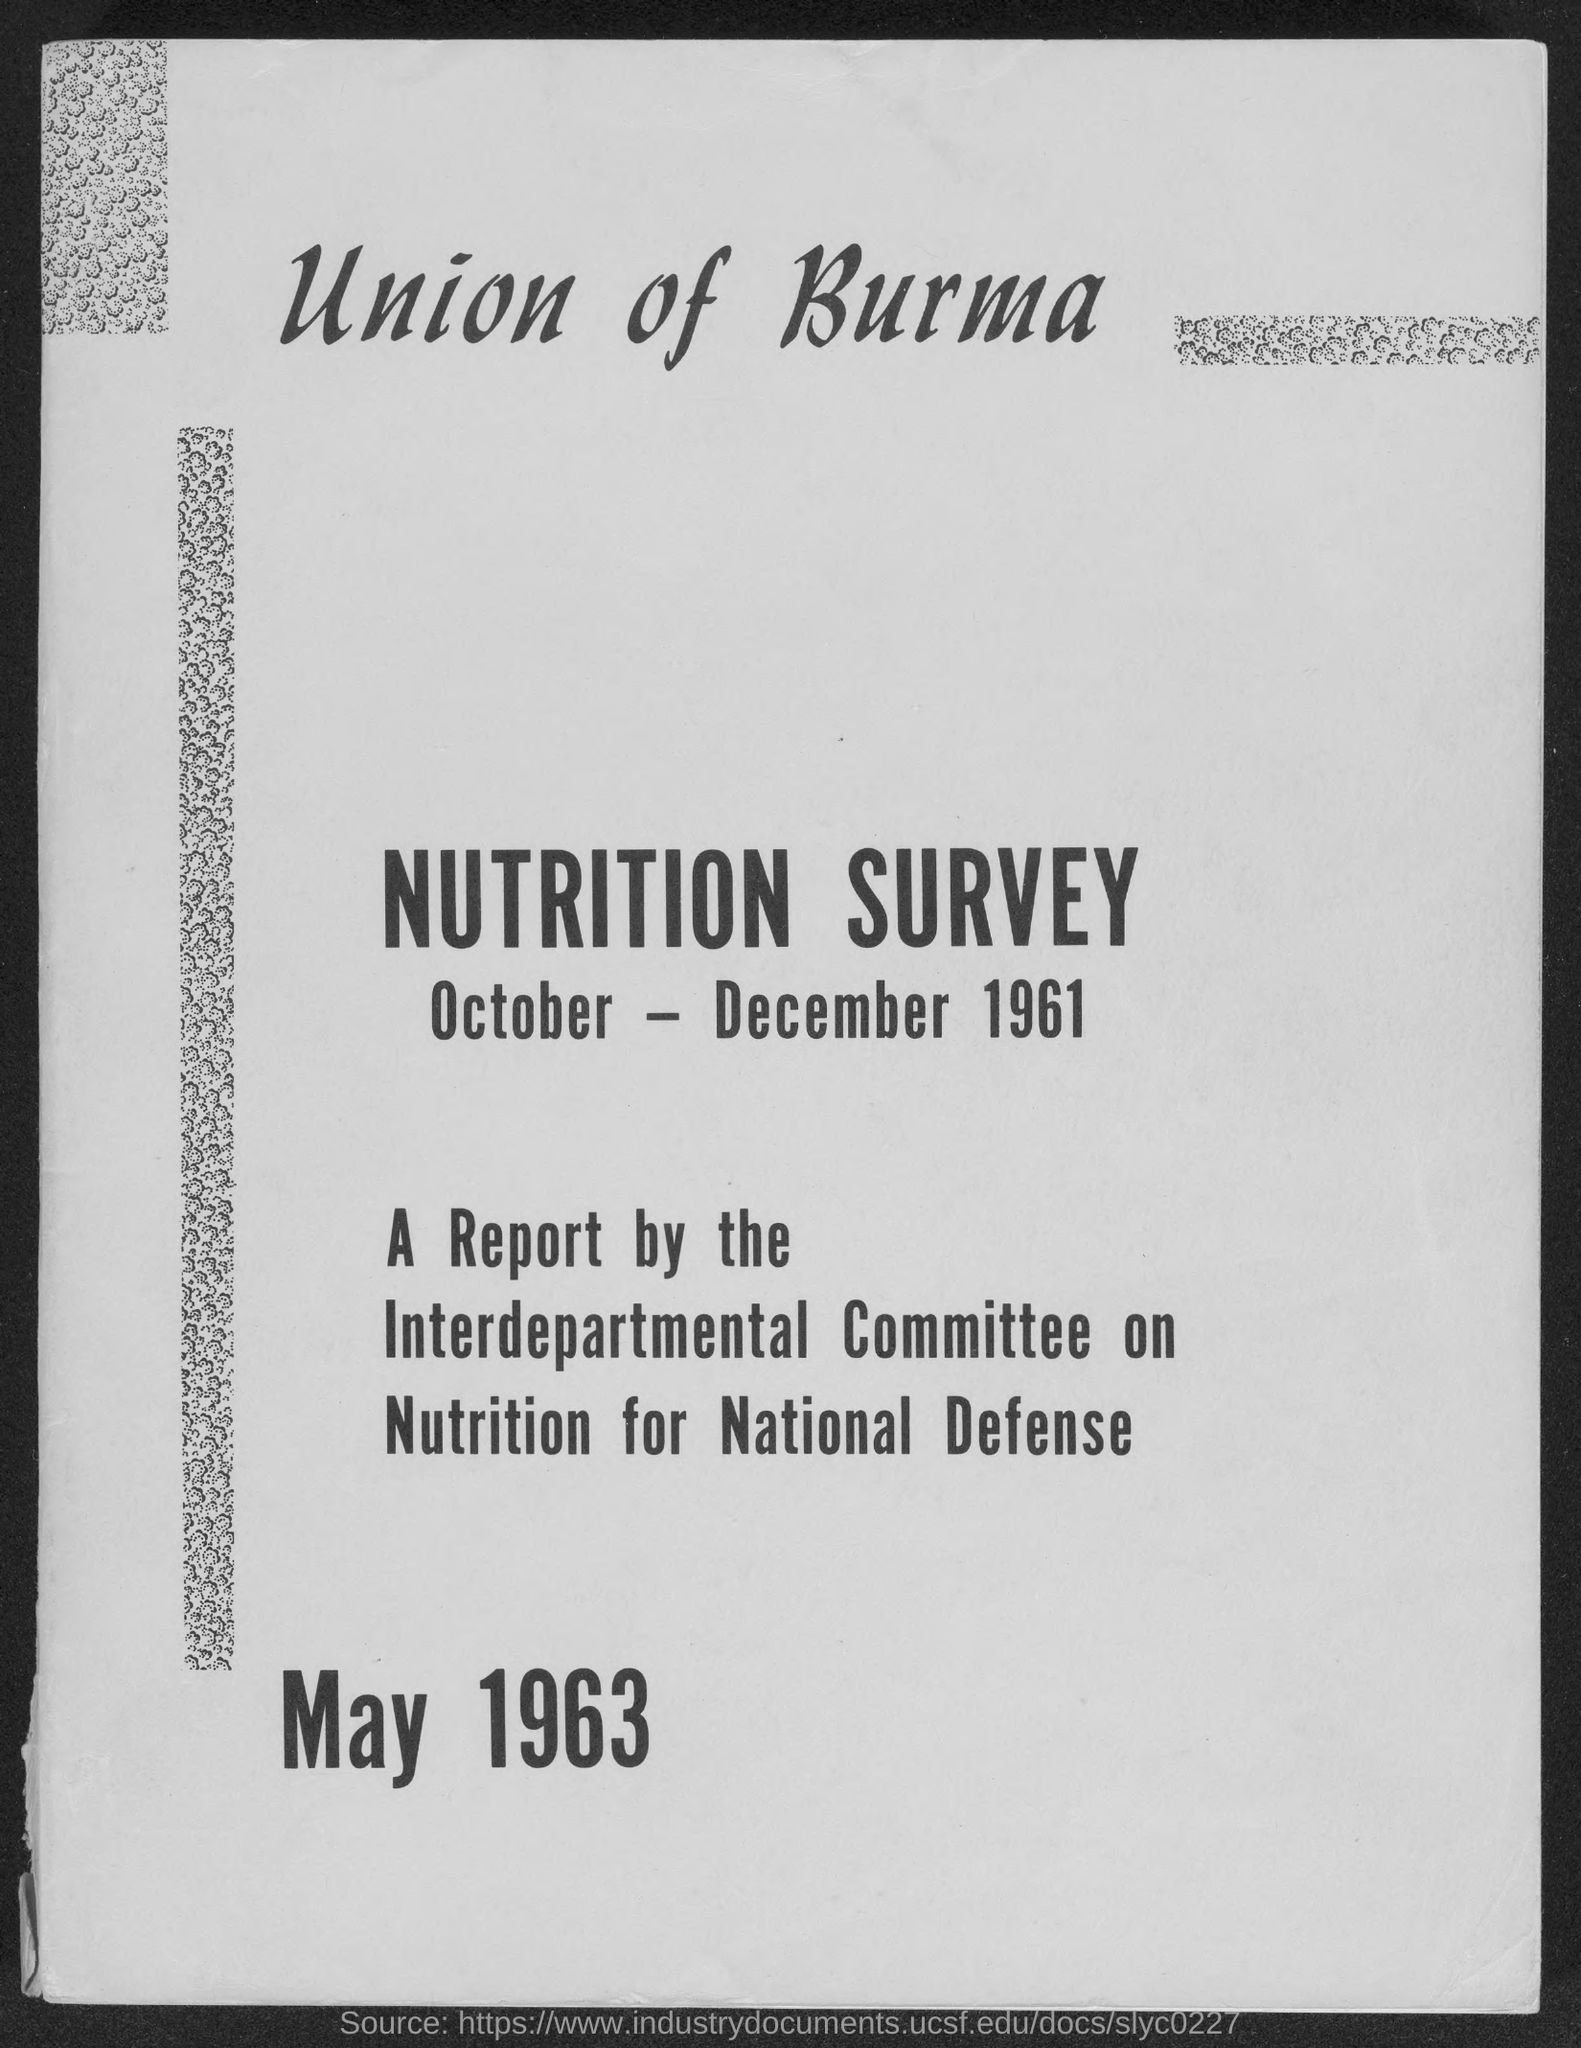Specify some key components in this picture. The month and year at the bottom of the page are May 1963. 